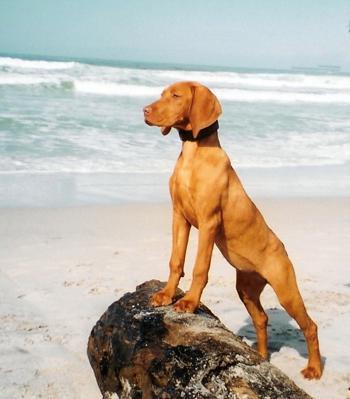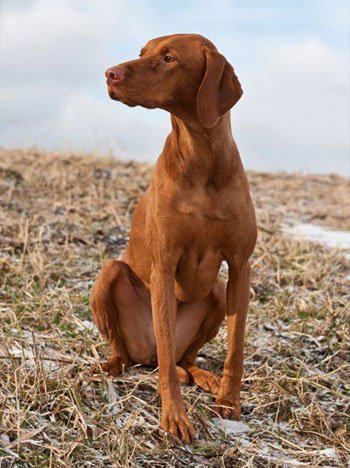The first image is the image on the left, the second image is the image on the right. Assess this claim about the two images: "One image shows two dogs with the same coloring sitting side-by-side with their chests facing the camera, and the other image shows one dog in a standing pose outdoors.". Correct or not? Answer yes or no. No. The first image is the image on the left, the second image is the image on the right. Given the left and right images, does the statement "The left image contains exactly two dogs." hold true? Answer yes or no. No. 